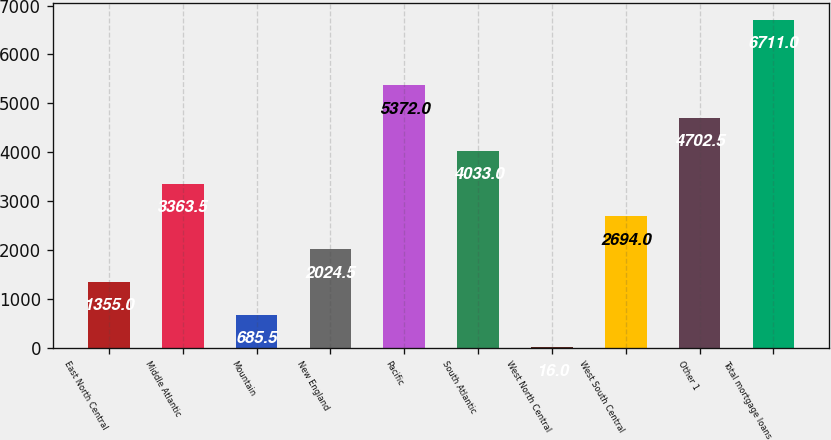<chart> <loc_0><loc_0><loc_500><loc_500><bar_chart><fcel>East North Central<fcel>Middle Atlantic<fcel>Mountain<fcel>New England<fcel>Pacific<fcel>South Atlantic<fcel>West North Central<fcel>West South Central<fcel>Other 1<fcel>Total mortgage loans<nl><fcel>1355<fcel>3363.5<fcel>685.5<fcel>2024.5<fcel>5372<fcel>4033<fcel>16<fcel>2694<fcel>4702.5<fcel>6711<nl></chart> 